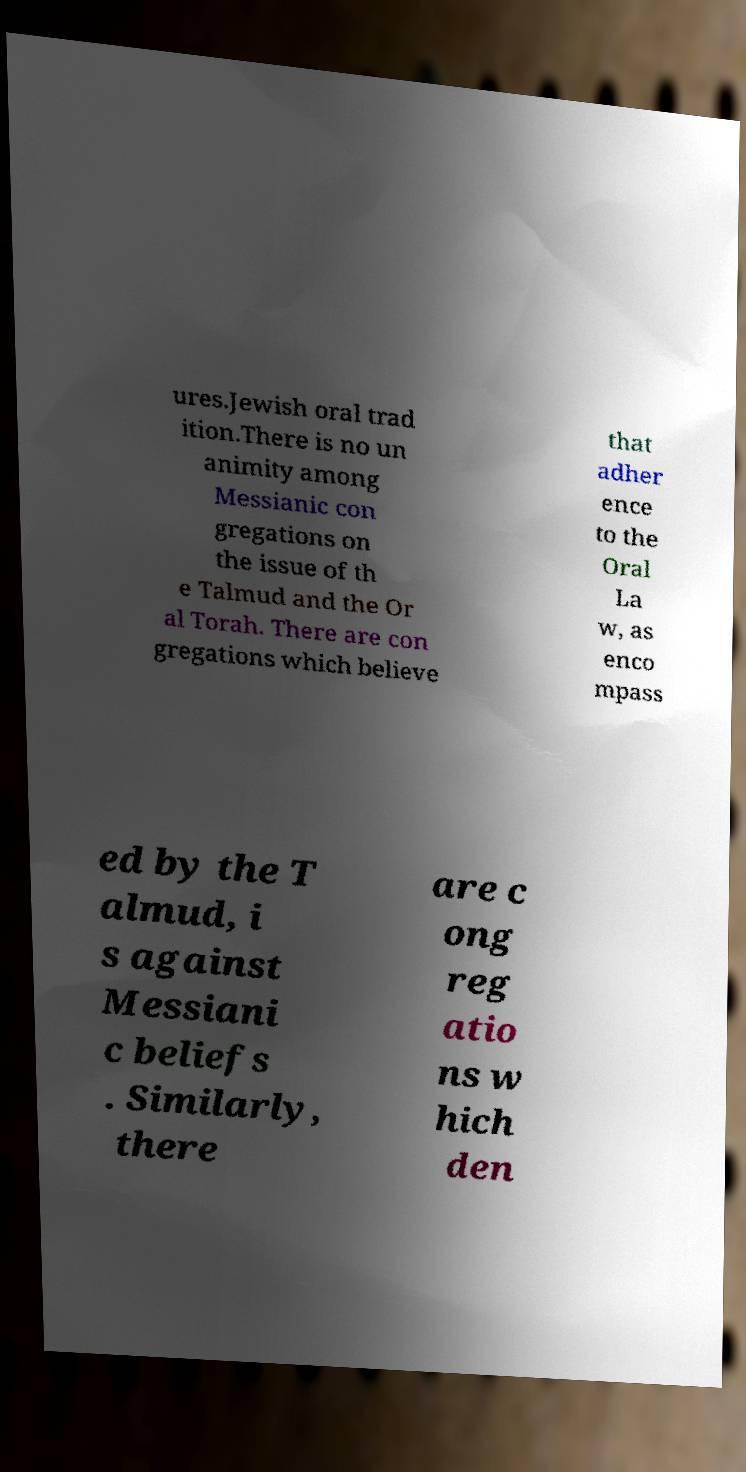Please identify and transcribe the text found in this image. ures.Jewish oral trad ition.There is no un animity among Messianic con gregations on the issue of th e Talmud and the Or al Torah. There are con gregations which believe that adher ence to the Oral La w, as enco mpass ed by the T almud, i s against Messiani c beliefs . Similarly, there are c ong reg atio ns w hich den 